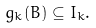Convert formula to latex. <formula><loc_0><loc_0><loc_500><loc_500>g _ { k } ( B ) \subseteq I _ { k } .</formula> 